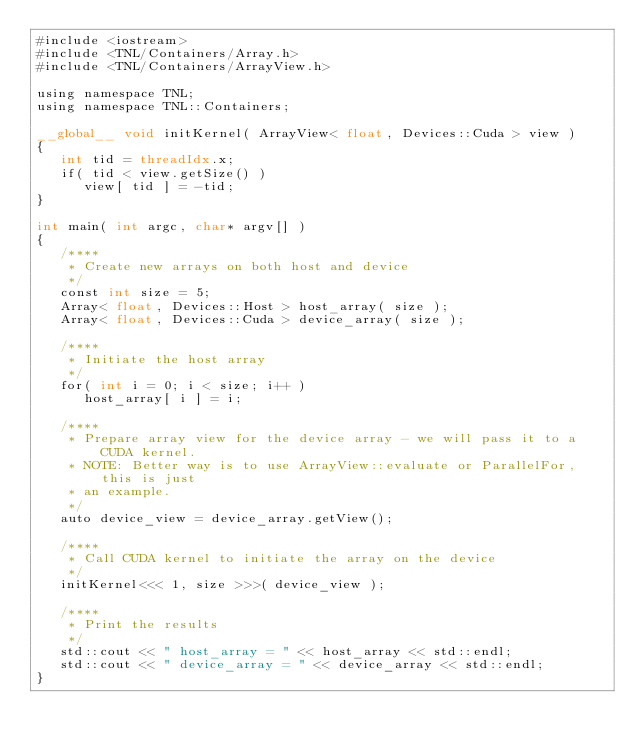<code> <loc_0><loc_0><loc_500><loc_500><_Cuda_>#include <iostream>
#include <TNL/Containers/Array.h>
#include <TNL/Containers/ArrayView.h>

using namespace TNL;
using namespace TNL::Containers;

__global__ void initKernel( ArrayView< float, Devices::Cuda > view )
{
   int tid = threadIdx.x;
   if( tid < view.getSize() )
      view[ tid ] = -tid;
}

int main( int argc, char* argv[] )
{
   /****
    * Create new arrays on both host and device
    */
   const int size = 5;
   Array< float, Devices::Host > host_array( size );
   Array< float, Devices::Cuda > device_array( size );

   /****
    * Initiate the host array
    */
   for( int i = 0; i < size; i++ )
      host_array[ i ] = i;

   /****
    * Prepare array view for the device array - we will pass it to a CUDA kernel.
    * NOTE: Better way is to use ArrayView::evaluate or ParallelFor, this is just
    * an example.
    */
   auto device_view = device_array.getView();

   /****
    * Call CUDA kernel to initiate the array on the device
    */
   initKernel<<< 1, size >>>( device_view );

   /****
    * Print the results
    */
   std::cout << " host_array = " << host_array << std::endl;
   std::cout << " device_array = " << device_array << std::endl;
}

</code> 